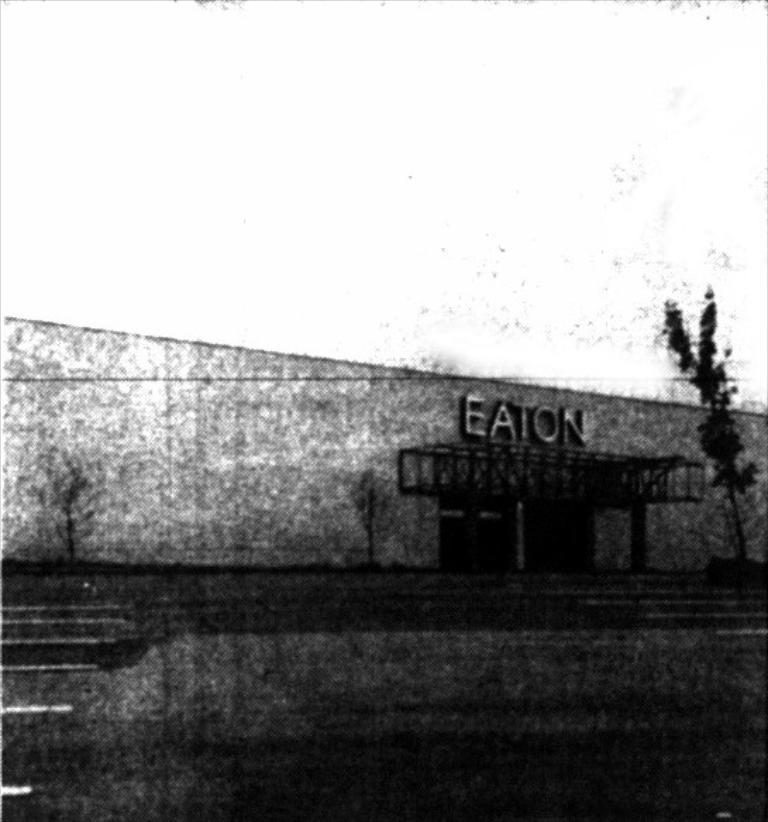<image>
Describe the image concisely. A black and white building with a large Eaton sign on it. 